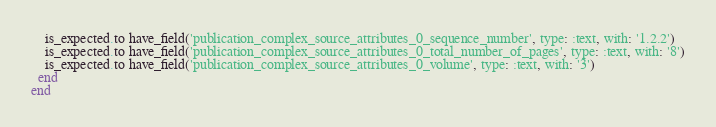<code> <loc_0><loc_0><loc_500><loc_500><_Ruby_>    is_expected.to have_field('publication_complex_source_attributes_0_sequence_number', type: :text, with: '1.2.2')
    is_expected.to have_field('publication_complex_source_attributes_0_total_number_of_pages', type: :text, with: '8')
    is_expected.to have_field('publication_complex_source_attributes_0_volume', type: :text, with: '3')
  end
end
</code> 